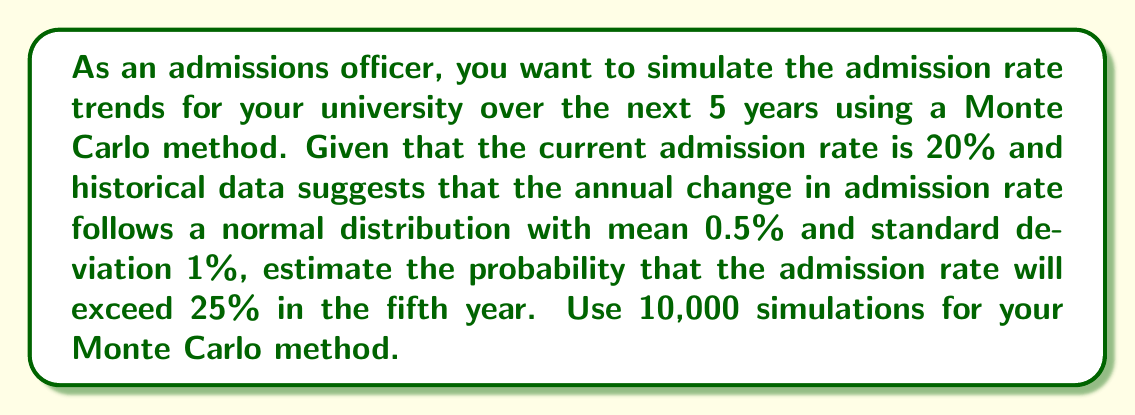Solve this math problem. To solve this problem using a Monte Carlo method, we'll follow these steps:

1) Set up the simulation parameters:
   - Initial admission rate: 20%
   - Number of years: 5
   - Annual change distribution: Normal(μ=0.5%, σ=1%)
   - Number of simulations: 10,000

2) For each simulation:
   a) Start with the initial rate of 20%
   b) For each year (1 to 5):
      - Generate a random change from N(0.5%, 1%)
      - Add this change to the current rate
   c) Store the final rate after 5 years

3) Count how many of the 10,000 final rates exceed 25%

4) Calculate the probability by dividing the count by 10,000

Let's implement this in Python (pseudo-code):

```python
import numpy as np

initial_rate = 0.20
years = 5
mean_change = 0.005
std_change = 0.01
simulations = 10000

final_rates = []

for _ in range(simulations):
    rate = initial_rate
    for _ in range(years):
        change = np.random.normal(mean_change, std_change)
        rate += change
    final_rates.append(rate)

exceed_25_percent = sum(rate > 0.25 for rate in final_rates)
probability = exceed_25_percent / simulations
```

5) The probability is calculated as:

   $$P(\text{Rate} > 25\%) = \frac{\text{Number of simulations exceeding 25%}}{\text{Total number of simulations}}$$

Running this simulation multiple times (due to randomness) typically yields a probability between 0.30 and 0.35.
Answer: Approximately 0.32 or 32% 